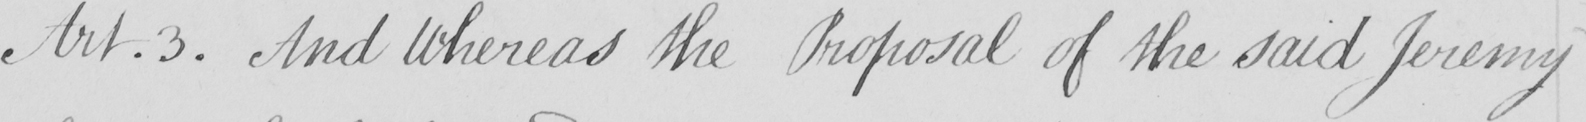Please provide the text content of this handwritten line. And Whereas the Proposal of the said Jeremy 